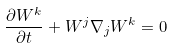<formula> <loc_0><loc_0><loc_500><loc_500>\frac { \partial W ^ { k } } { \partial t } + W ^ { j } \nabla _ { j } W ^ { k } = 0</formula> 